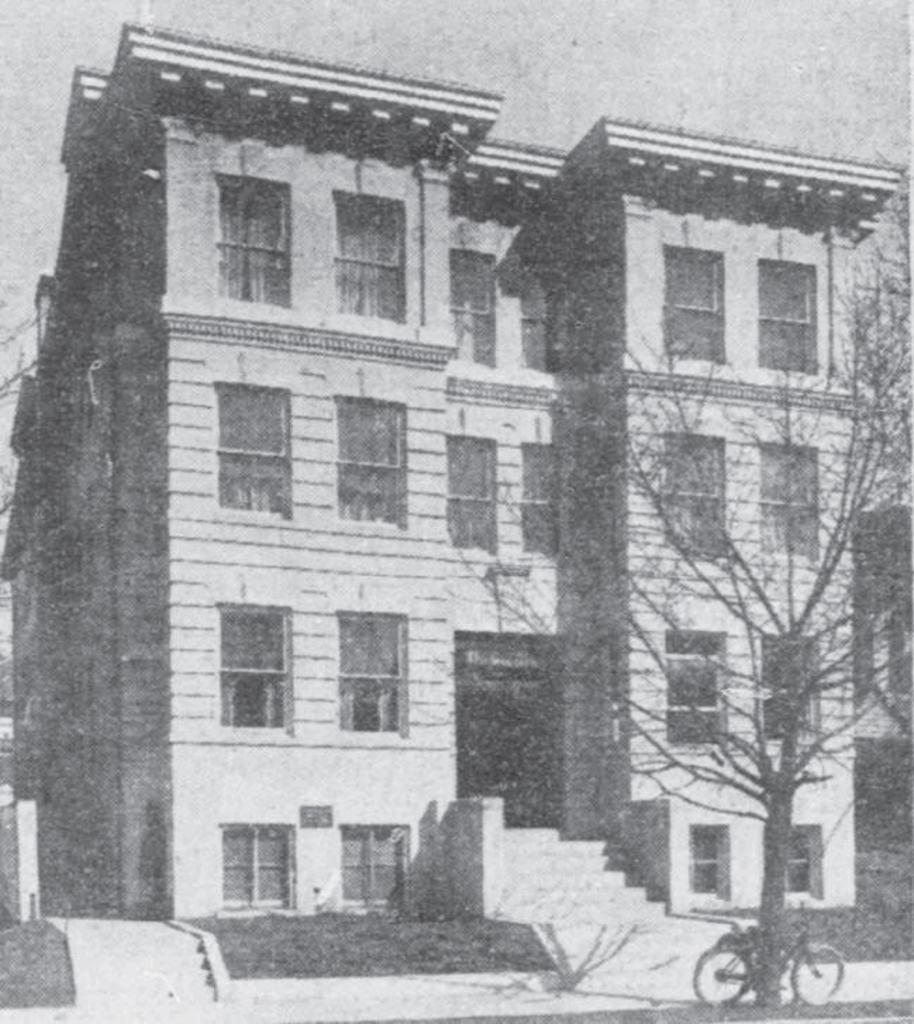Can you describe this image briefly? In this image there is one building in middle of this image and there is one tree at bottom of this image and there is one Bicycle at bottom of this image and there is a sky at top of this image. 